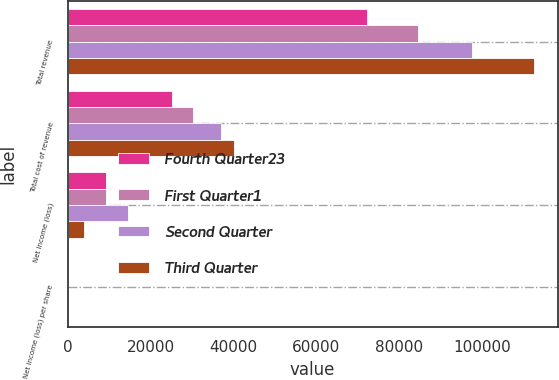<chart> <loc_0><loc_0><loc_500><loc_500><stacked_bar_chart><ecel><fcel>Total revenue<fcel>Total cost of revenue<fcel>Net income (loss)<fcel>Net income (loss) per share<nl><fcel>Fourth Quarter23<fcel>72150<fcel>25120<fcel>9264<fcel>5.58<nl><fcel>First Quarter1<fcel>84535<fcel>30141<fcel>9264<fcel>0.16<nl><fcel>Second Quarter<fcel>97510<fcel>37078<fcel>14503<fcel>0.24<nl><fcel>Third Quarter<fcel>112604<fcel>40097<fcel>4050<fcel>0.07<nl></chart> 